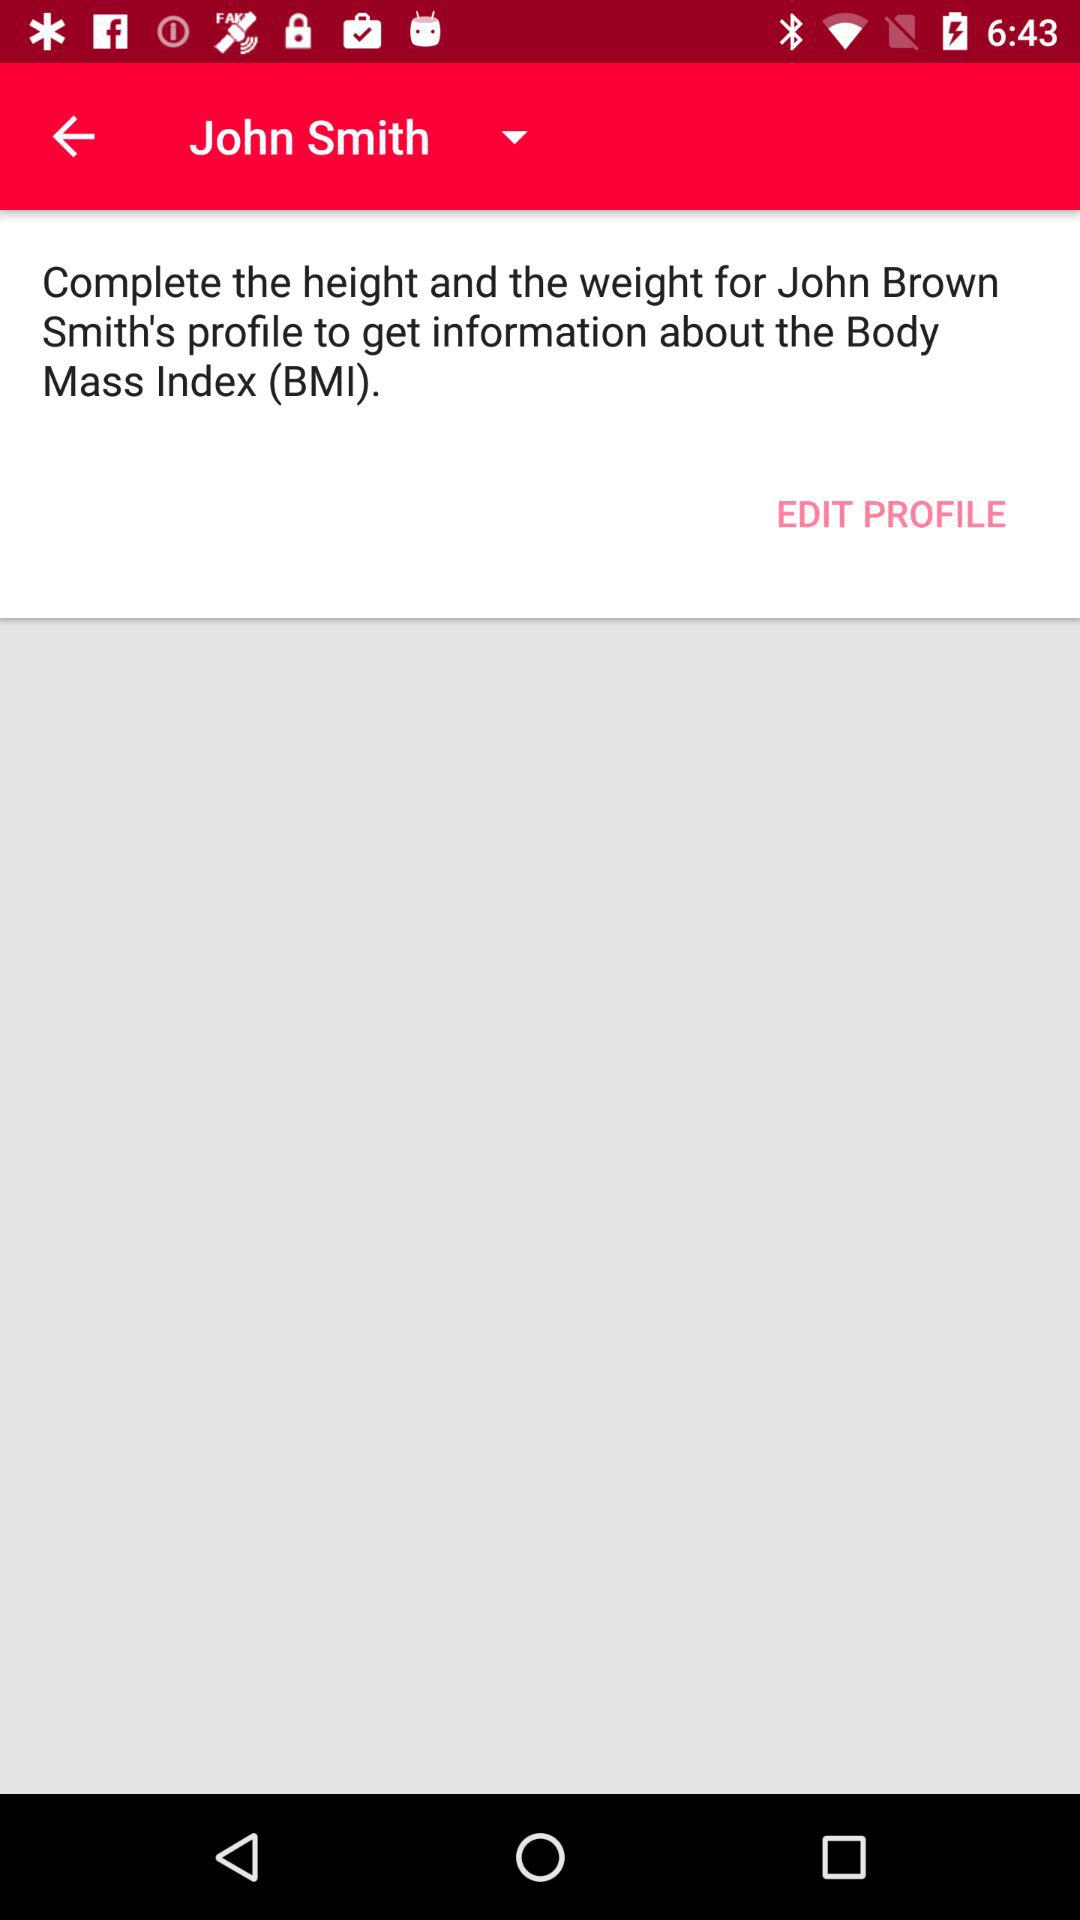What is John Smith's BMI?
When the provided information is insufficient, respond with <no answer>. <no answer> 